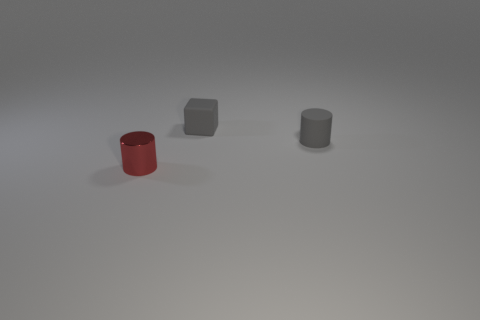What number of cylinders are small gray rubber things or small objects?
Make the answer very short. 2. What is the color of the cylinder that is in front of the gray matte object that is on the right side of the cube?
Your response must be concise. Red. Is the number of small metal cylinders that are behind the small gray matte cube less than the number of tiny gray matte cubes behind the red cylinder?
Make the answer very short. Yes. There is a gray cylinder; does it have the same size as the object left of the cube?
Provide a short and direct response. Yes. What is the shape of the small thing that is both in front of the small gray matte block and left of the tiny gray matte cylinder?
Your answer should be very brief. Cylinder. There is a gray block that is made of the same material as the small gray cylinder; what size is it?
Give a very brief answer. Small. How many small gray blocks are behind the cylinder to the right of the small red metal thing?
Give a very brief answer. 1. Does the tiny cylinder to the right of the red shiny object have the same material as the tiny gray cube?
Provide a short and direct response. Yes. Is there anything else that has the same material as the small gray cylinder?
Your answer should be compact. Yes. What size is the rubber object to the left of the small gray thing that is right of the matte cube?
Offer a very short reply. Small. 